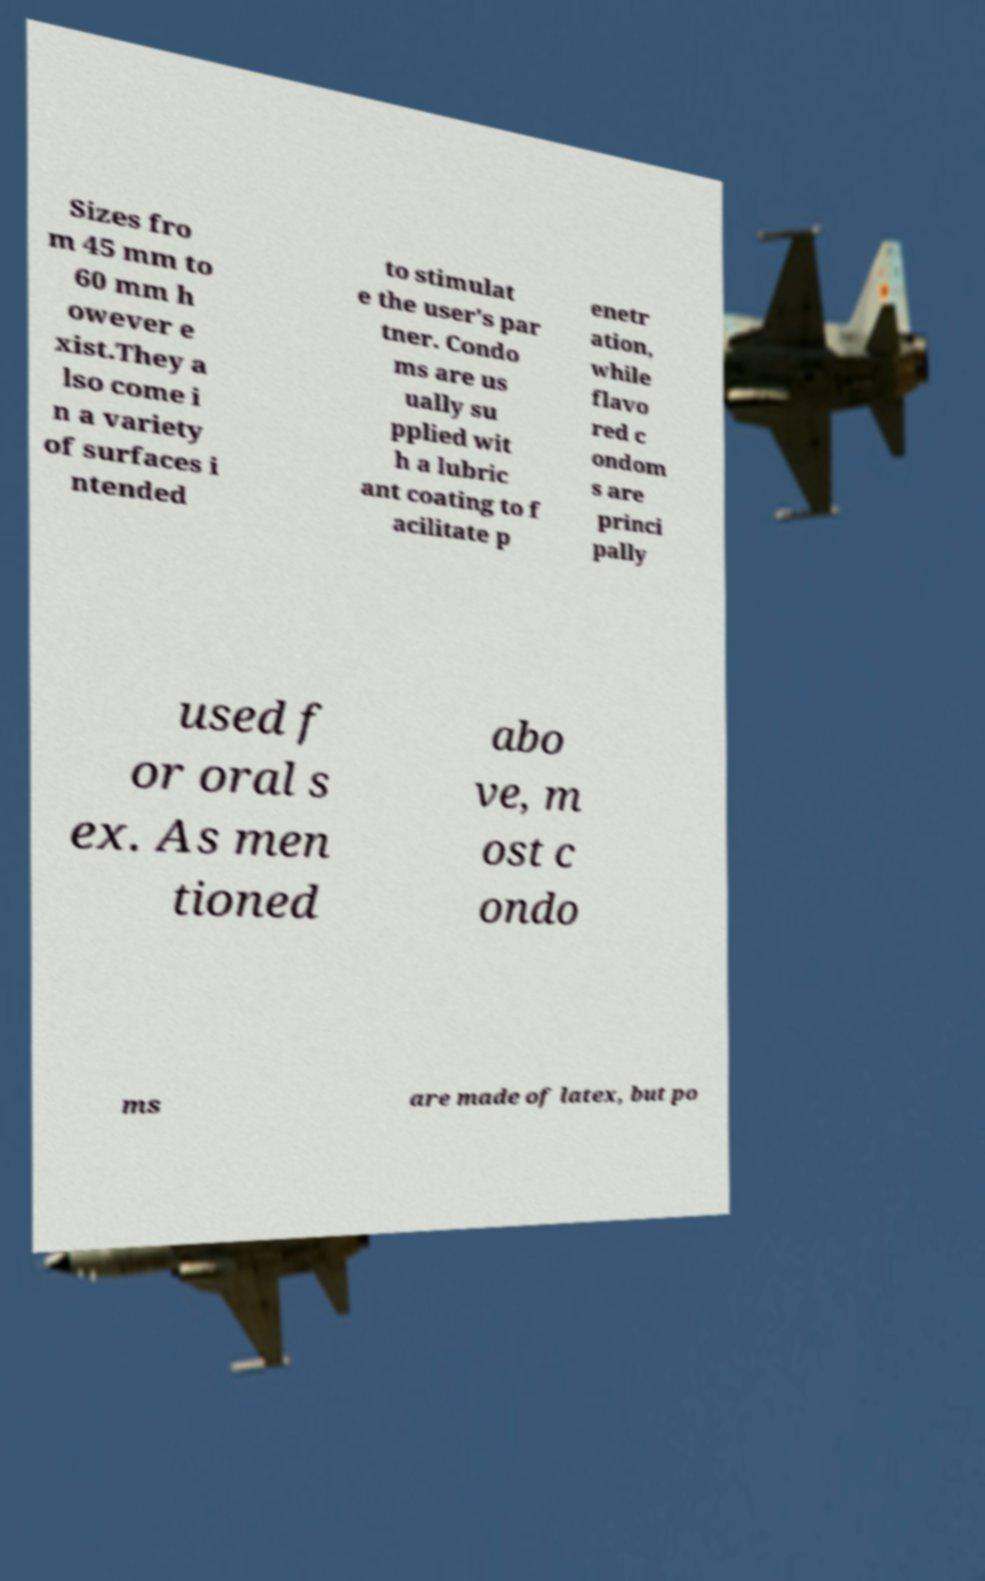Please read and relay the text visible in this image. What does it say? Sizes fro m 45 mm to 60 mm h owever e xist.They a lso come i n a variety of surfaces i ntended to stimulat e the user's par tner. Condo ms are us ually su pplied wit h a lubric ant coating to f acilitate p enetr ation, while flavo red c ondom s are princi pally used f or oral s ex. As men tioned abo ve, m ost c ondo ms are made of latex, but po 